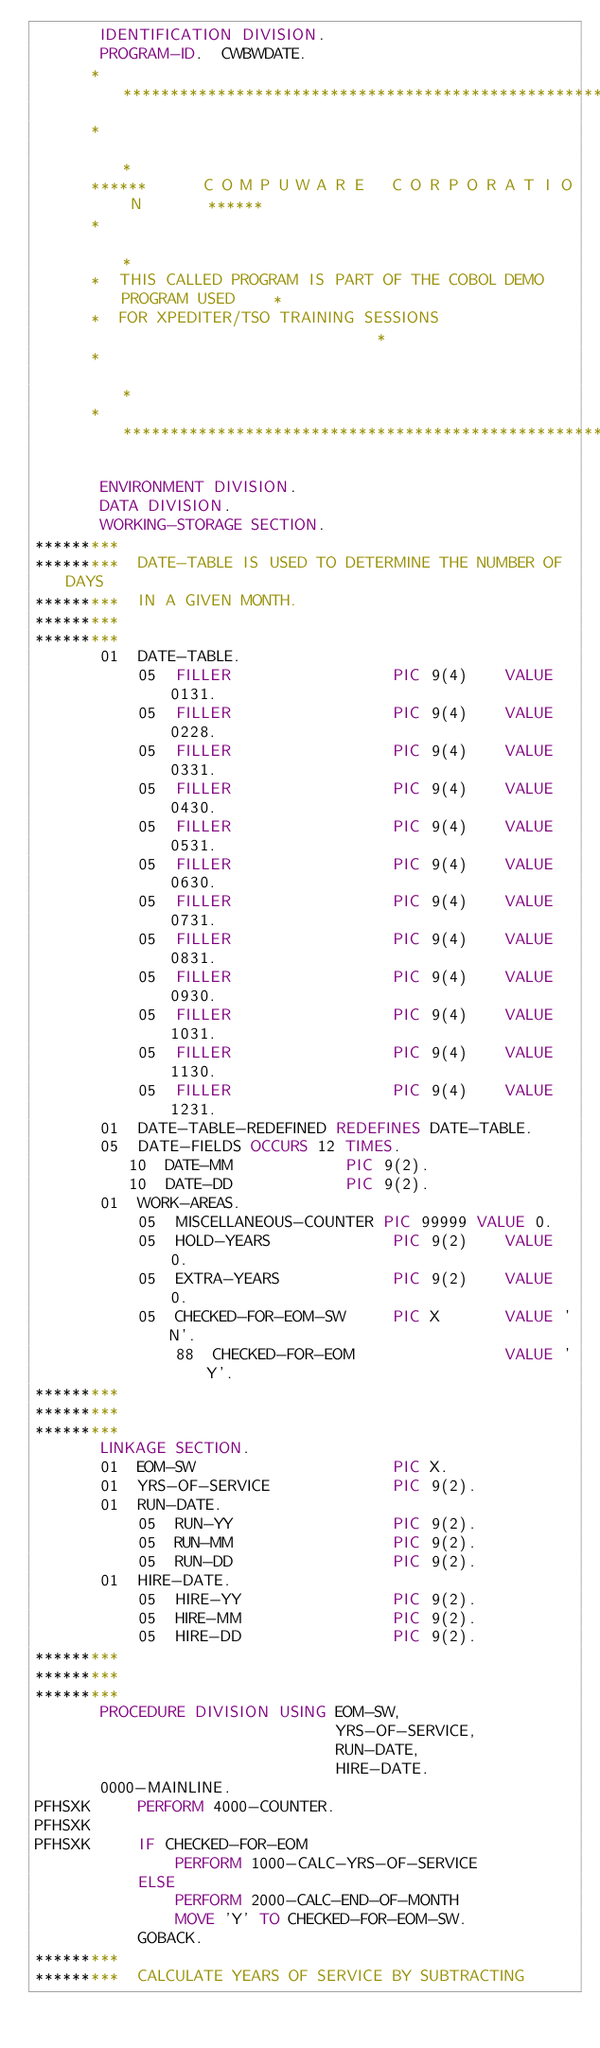<code> <loc_0><loc_0><loc_500><loc_500><_COBOL_>       IDENTIFICATION DIVISION.
       PROGRAM-ID.  CWBWDATE.
      ******************************************************************
      *                                                                *
      ******      C O M P U W A R E   C O R P O R A T I O N       ******
      *                                                                *
      *  THIS CALLED PROGRAM IS PART OF THE COBOL DEMO PROGRAM USED    *
      *  FOR XPEDITER/TSO TRAINING SESSIONS                            *
      *                                                                *
      ******************************************************************

       ENVIRONMENT DIVISION.
       DATA DIVISION.
       WORKING-STORAGE SECTION.
*********
*********  DATE-TABLE IS USED TO DETERMINE THE NUMBER OF DAYS
*********  IN A GIVEN MONTH.
*********
*********
       01  DATE-TABLE.
           05  FILLER                 PIC 9(4)    VALUE 0131.
           05  FILLER                 PIC 9(4)    VALUE 0228.
           05  FILLER                 PIC 9(4)    VALUE 0331.
           05  FILLER                 PIC 9(4)    VALUE 0430.
           05  FILLER                 PIC 9(4)    VALUE 0531.
           05  FILLER                 PIC 9(4)    VALUE 0630.
           05  FILLER                 PIC 9(4)    VALUE 0731.
           05  FILLER                 PIC 9(4)    VALUE 0831.
           05  FILLER                 PIC 9(4)    VALUE 0930.
           05  FILLER                 PIC 9(4)    VALUE 1031.
           05  FILLER                 PIC 9(4)    VALUE 1130.
           05  FILLER                 PIC 9(4)    VALUE 1231.
       01  DATE-TABLE-REDEFINED REDEFINES DATE-TABLE.
       05  DATE-FIELDS OCCURS 12 TIMES.
          10  DATE-MM            PIC 9(2).
          10  DATE-DD            PIC 9(2).
       01  WORK-AREAS.
           05  MISCELLANEOUS-COUNTER PIC 99999 VALUE 0.
           05  HOLD-YEARS             PIC 9(2)    VALUE 0.
           05  EXTRA-YEARS            PIC 9(2)    VALUE 0.
           05  CHECKED-FOR-EOM-SW     PIC X       VALUE 'N'.
               88  CHECKED-FOR-EOM                VALUE 'Y'.
*********
*********
*********
       LINKAGE SECTION.
       01  EOM-SW                     PIC X.
       01  YRS-OF-SERVICE             PIC 9(2).
       01  RUN-DATE.
           05  RUN-YY                 PIC 9(2).
           05  RUN-MM                 PIC 9(2).
           05  RUN-DD                 PIC 9(2).
       01  HIRE-DATE.
           05  HIRE-YY                PIC 9(2).
           05  HIRE-MM                PIC 9(2).
           05  HIRE-DD                PIC 9(2).
*********
*********
*********
       PROCEDURE DIVISION USING EOM-SW,
                                YRS-OF-SERVICE,
                                RUN-DATE,
                                HIRE-DATE.
       0000-MAINLINE.
PFHSXK     PERFORM 4000-COUNTER.
PFHSXK
PFHSXK     IF CHECKED-FOR-EOM
               PERFORM 1000-CALC-YRS-OF-SERVICE
           ELSE
               PERFORM 2000-CALC-END-OF-MONTH
               MOVE 'Y' TO CHECKED-FOR-EOM-SW.
           GOBACK.
*********
*********  CALCULATE YEARS OF SERVICE BY SUBTRACTING</code> 